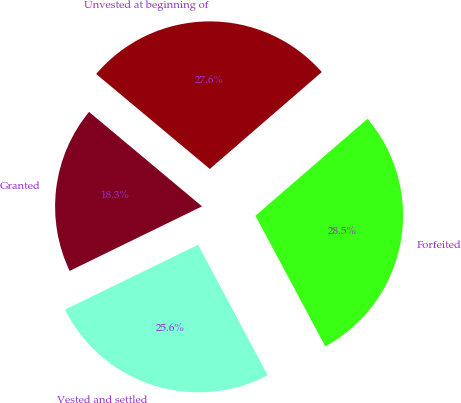Convert chart to OTSL. <chart><loc_0><loc_0><loc_500><loc_500><pie_chart><fcel>Unvested at beginning of<fcel>Granted<fcel>Vested and settled<fcel>Forfeited<nl><fcel>27.57%<fcel>18.3%<fcel>25.59%<fcel>28.54%<nl></chart> 